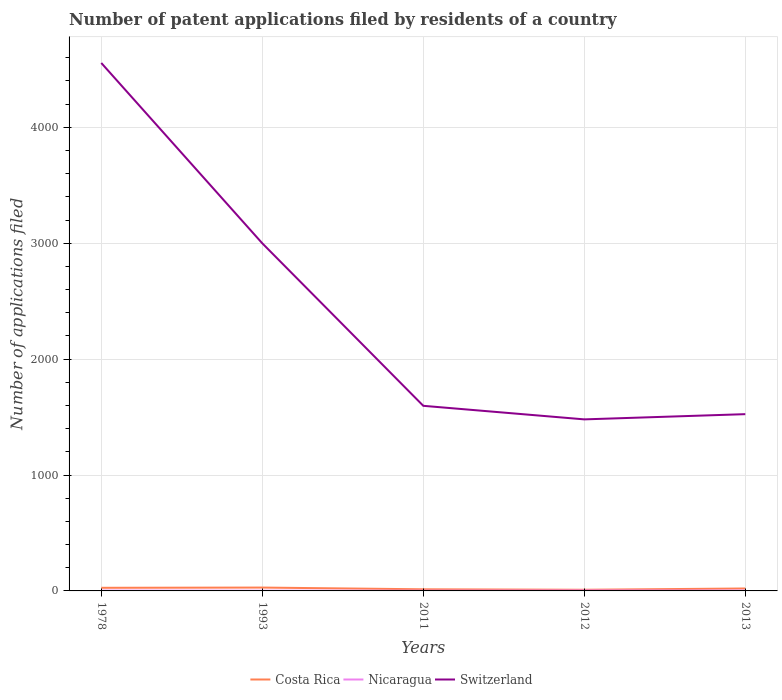Does the line corresponding to Nicaragua intersect with the line corresponding to Switzerland?
Offer a terse response. No. Across all years, what is the maximum number of applications filed in Nicaragua?
Offer a terse response. 2. What is the difference between the highest and the second highest number of applications filed in Switzerland?
Provide a succinct answer. 3075. Is the number of applications filed in Switzerland strictly greater than the number of applications filed in Nicaragua over the years?
Ensure brevity in your answer.  No. Does the graph contain any zero values?
Ensure brevity in your answer.  No. Does the graph contain grids?
Provide a short and direct response. Yes. Where does the legend appear in the graph?
Ensure brevity in your answer.  Bottom center. How many legend labels are there?
Keep it short and to the point. 3. How are the legend labels stacked?
Provide a short and direct response. Horizontal. What is the title of the graph?
Your answer should be compact. Number of patent applications filed by residents of a country. What is the label or title of the X-axis?
Your answer should be compact. Years. What is the label or title of the Y-axis?
Your response must be concise. Number of applications filed. What is the Number of applications filed of Costa Rica in 1978?
Your response must be concise. 27. What is the Number of applications filed of Nicaragua in 1978?
Your answer should be compact. 3. What is the Number of applications filed in Switzerland in 1978?
Make the answer very short. 4555. What is the Number of applications filed of Nicaragua in 1993?
Ensure brevity in your answer.  2. What is the Number of applications filed in Switzerland in 1993?
Offer a terse response. 2999. What is the Number of applications filed of Switzerland in 2011?
Offer a very short reply. 1597. What is the Number of applications filed in Costa Rica in 2012?
Your answer should be compact. 10. What is the Number of applications filed in Nicaragua in 2012?
Your response must be concise. 4. What is the Number of applications filed of Switzerland in 2012?
Your answer should be compact. 1480. What is the Number of applications filed of Costa Rica in 2013?
Your answer should be compact. 21. What is the Number of applications filed of Switzerland in 2013?
Provide a succinct answer. 1525. Across all years, what is the maximum Number of applications filed of Costa Rica?
Your answer should be very brief. 29. Across all years, what is the maximum Number of applications filed in Switzerland?
Give a very brief answer. 4555. Across all years, what is the minimum Number of applications filed of Costa Rica?
Your answer should be very brief. 10. Across all years, what is the minimum Number of applications filed of Nicaragua?
Make the answer very short. 2. Across all years, what is the minimum Number of applications filed in Switzerland?
Ensure brevity in your answer.  1480. What is the total Number of applications filed in Costa Rica in the graph?
Make the answer very short. 101. What is the total Number of applications filed of Switzerland in the graph?
Give a very brief answer. 1.22e+04. What is the difference between the Number of applications filed in Costa Rica in 1978 and that in 1993?
Your response must be concise. -2. What is the difference between the Number of applications filed of Nicaragua in 1978 and that in 1993?
Make the answer very short. 1. What is the difference between the Number of applications filed of Switzerland in 1978 and that in 1993?
Give a very brief answer. 1556. What is the difference between the Number of applications filed in Nicaragua in 1978 and that in 2011?
Make the answer very short. 1. What is the difference between the Number of applications filed in Switzerland in 1978 and that in 2011?
Give a very brief answer. 2958. What is the difference between the Number of applications filed of Costa Rica in 1978 and that in 2012?
Give a very brief answer. 17. What is the difference between the Number of applications filed of Nicaragua in 1978 and that in 2012?
Offer a very short reply. -1. What is the difference between the Number of applications filed of Switzerland in 1978 and that in 2012?
Offer a very short reply. 3075. What is the difference between the Number of applications filed of Nicaragua in 1978 and that in 2013?
Make the answer very short. 0. What is the difference between the Number of applications filed in Switzerland in 1978 and that in 2013?
Make the answer very short. 3030. What is the difference between the Number of applications filed in Switzerland in 1993 and that in 2011?
Provide a short and direct response. 1402. What is the difference between the Number of applications filed in Switzerland in 1993 and that in 2012?
Give a very brief answer. 1519. What is the difference between the Number of applications filed in Nicaragua in 1993 and that in 2013?
Your response must be concise. -1. What is the difference between the Number of applications filed in Switzerland in 1993 and that in 2013?
Your answer should be very brief. 1474. What is the difference between the Number of applications filed of Costa Rica in 2011 and that in 2012?
Your response must be concise. 4. What is the difference between the Number of applications filed in Switzerland in 2011 and that in 2012?
Offer a terse response. 117. What is the difference between the Number of applications filed in Nicaragua in 2011 and that in 2013?
Provide a short and direct response. -1. What is the difference between the Number of applications filed in Nicaragua in 2012 and that in 2013?
Offer a very short reply. 1. What is the difference between the Number of applications filed of Switzerland in 2012 and that in 2013?
Offer a very short reply. -45. What is the difference between the Number of applications filed of Costa Rica in 1978 and the Number of applications filed of Switzerland in 1993?
Give a very brief answer. -2972. What is the difference between the Number of applications filed of Nicaragua in 1978 and the Number of applications filed of Switzerland in 1993?
Provide a short and direct response. -2996. What is the difference between the Number of applications filed of Costa Rica in 1978 and the Number of applications filed of Nicaragua in 2011?
Your answer should be very brief. 25. What is the difference between the Number of applications filed of Costa Rica in 1978 and the Number of applications filed of Switzerland in 2011?
Ensure brevity in your answer.  -1570. What is the difference between the Number of applications filed of Nicaragua in 1978 and the Number of applications filed of Switzerland in 2011?
Your answer should be compact. -1594. What is the difference between the Number of applications filed of Costa Rica in 1978 and the Number of applications filed of Switzerland in 2012?
Your answer should be very brief. -1453. What is the difference between the Number of applications filed in Nicaragua in 1978 and the Number of applications filed in Switzerland in 2012?
Offer a very short reply. -1477. What is the difference between the Number of applications filed in Costa Rica in 1978 and the Number of applications filed in Nicaragua in 2013?
Ensure brevity in your answer.  24. What is the difference between the Number of applications filed of Costa Rica in 1978 and the Number of applications filed of Switzerland in 2013?
Keep it short and to the point. -1498. What is the difference between the Number of applications filed of Nicaragua in 1978 and the Number of applications filed of Switzerland in 2013?
Make the answer very short. -1522. What is the difference between the Number of applications filed in Costa Rica in 1993 and the Number of applications filed in Nicaragua in 2011?
Make the answer very short. 27. What is the difference between the Number of applications filed in Costa Rica in 1993 and the Number of applications filed in Switzerland in 2011?
Provide a short and direct response. -1568. What is the difference between the Number of applications filed in Nicaragua in 1993 and the Number of applications filed in Switzerland in 2011?
Offer a very short reply. -1595. What is the difference between the Number of applications filed in Costa Rica in 1993 and the Number of applications filed in Switzerland in 2012?
Your answer should be compact. -1451. What is the difference between the Number of applications filed in Nicaragua in 1993 and the Number of applications filed in Switzerland in 2012?
Make the answer very short. -1478. What is the difference between the Number of applications filed of Costa Rica in 1993 and the Number of applications filed of Nicaragua in 2013?
Keep it short and to the point. 26. What is the difference between the Number of applications filed of Costa Rica in 1993 and the Number of applications filed of Switzerland in 2013?
Offer a very short reply. -1496. What is the difference between the Number of applications filed in Nicaragua in 1993 and the Number of applications filed in Switzerland in 2013?
Offer a terse response. -1523. What is the difference between the Number of applications filed in Costa Rica in 2011 and the Number of applications filed in Switzerland in 2012?
Offer a terse response. -1466. What is the difference between the Number of applications filed of Nicaragua in 2011 and the Number of applications filed of Switzerland in 2012?
Give a very brief answer. -1478. What is the difference between the Number of applications filed of Costa Rica in 2011 and the Number of applications filed of Switzerland in 2013?
Your answer should be compact. -1511. What is the difference between the Number of applications filed of Nicaragua in 2011 and the Number of applications filed of Switzerland in 2013?
Make the answer very short. -1523. What is the difference between the Number of applications filed of Costa Rica in 2012 and the Number of applications filed of Switzerland in 2013?
Your answer should be very brief. -1515. What is the difference between the Number of applications filed of Nicaragua in 2012 and the Number of applications filed of Switzerland in 2013?
Your answer should be very brief. -1521. What is the average Number of applications filed of Costa Rica per year?
Provide a succinct answer. 20.2. What is the average Number of applications filed of Switzerland per year?
Provide a short and direct response. 2431.2. In the year 1978, what is the difference between the Number of applications filed in Costa Rica and Number of applications filed in Nicaragua?
Provide a succinct answer. 24. In the year 1978, what is the difference between the Number of applications filed of Costa Rica and Number of applications filed of Switzerland?
Your answer should be compact. -4528. In the year 1978, what is the difference between the Number of applications filed of Nicaragua and Number of applications filed of Switzerland?
Make the answer very short. -4552. In the year 1993, what is the difference between the Number of applications filed of Costa Rica and Number of applications filed of Switzerland?
Provide a short and direct response. -2970. In the year 1993, what is the difference between the Number of applications filed of Nicaragua and Number of applications filed of Switzerland?
Offer a very short reply. -2997. In the year 2011, what is the difference between the Number of applications filed of Costa Rica and Number of applications filed of Switzerland?
Offer a terse response. -1583. In the year 2011, what is the difference between the Number of applications filed in Nicaragua and Number of applications filed in Switzerland?
Make the answer very short. -1595. In the year 2012, what is the difference between the Number of applications filed of Costa Rica and Number of applications filed of Switzerland?
Make the answer very short. -1470. In the year 2012, what is the difference between the Number of applications filed in Nicaragua and Number of applications filed in Switzerland?
Make the answer very short. -1476. In the year 2013, what is the difference between the Number of applications filed of Costa Rica and Number of applications filed of Switzerland?
Keep it short and to the point. -1504. In the year 2013, what is the difference between the Number of applications filed in Nicaragua and Number of applications filed in Switzerland?
Ensure brevity in your answer.  -1522. What is the ratio of the Number of applications filed of Costa Rica in 1978 to that in 1993?
Offer a very short reply. 0.93. What is the ratio of the Number of applications filed of Nicaragua in 1978 to that in 1993?
Make the answer very short. 1.5. What is the ratio of the Number of applications filed in Switzerland in 1978 to that in 1993?
Give a very brief answer. 1.52. What is the ratio of the Number of applications filed of Costa Rica in 1978 to that in 2011?
Offer a terse response. 1.93. What is the ratio of the Number of applications filed of Nicaragua in 1978 to that in 2011?
Make the answer very short. 1.5. What is the ratio of the Number of applications filed of Switzerland in 1978 to that in 2011?
Your answer should be compact. 2.85. What is the ratio of the Number of applications filed of Costa Rica in 1978 to that in 2012?
Give a very brief answer. 2.7. What is the ratio of the Number of applications filed in Nicaragua in 1978 to that in 2012?
Give a very brief answer. 0.75. What is the ratio of the Number of applications filed in Switzerland in 1978 to that in 2012?
Provide a short and direct response. 3.08. What is the ratio of the Number of applications filed in Costa Rica in 1978 to that in 2013?
Your answer should be compact. 1.29. What is the ratio of the Number of applications filed in Nicaragua in 1978 to that in 2013?
Provide a short and direct response. 1. What is the ratio of the Number of applications filed of Switzerland in 1978 to that in 2013?
Your answer should be very brief. 2.99. What is the ratio of the Number of applications filed in Costa Rica in 1993 to that in 2011?
Provide a succinct answer. 2.07. What is the ratio of the Number of applications filed of Switzerland in 1993 to that in 2011?
Give a very brief answer. 1.88. What is the ratio of the Number of applications filed of Nicaragua in 1993 to that in 2012?
Keep it short and to the point. 0.5. What is the ratio of the Number of applications filed in Switzerland in 1993 to that in 2012?
Make the answer very short. 2.03. What is the ratio of the Number of applications filed of Costa Rica in 1993 to that in 2013?
Your answer should be compact. 1.38. What is the ratio of the Number of applications filed of Switzerland in 1993 to that in 2013?
Your answer should be very brief. 1.97. What is the ratio of the Number of applications filed in Switzerland in 2011 to that in 2012?
Ensure brevity in your answer.  1.08. What is the ratio of the Number of applications filed of Nicaragua in 2011 to that in 2013?
Ensure brevity in your answer.  0.67. What is the ratio of the Number of applications filed in Switzerland in 2011 to that in 2013?
Offer a terse response. 1.05. What is the ratio of the Number of applications filed of Costa Rica in 2012 to that in 2013?
Keep it short and to the point. 0.48. What is the ratio of the Number of applications filed in Switzerland in 2012 to that in 2013?
Your answer should be compact. 0.97. What is the difference between the highest and the second highest Number of applications filed in Costa Rica?
Your answer should be very brief. 2. What is the difference between the highest and the second highest Number of applications filed of Nicaragua?
Give a very brief answer. 1. What is the difference between the highest and the second highest Number of applications filed of Switzerland?
Your response must be concise. 1556. What is the difference between the highest and the lowest Number of applications filed of Costa Rica?
Provide a succinct answer. 19. What is the difference between the highest and the lowest Number of applications filed in Switzerland?
Ensure brevity in your answer.  3075. 